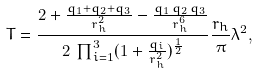<formula> <loc_0><loc_0><loc_500><loc_500>T = \frac { 2 + \frac { q _ { 1 } + q _ { 2 } + q _ { 3 } } { r ^ { 2 } _ { h } } - \frac { q _ { 1 } \, q _ { 2 } \, q _ { 3 } } { r ^ { 6 } _ { h } } } { 2 \, \prod ^ { 3 } _ { i = 1 } ( 1 + \frac { q _ { i } } { r _ { h } ^ { 2 } } ) ^ { \frac { 1 } { 2 } } } \frac { r _ { h } } { \pi } \lambda ^ { 2 } ,</formula> 